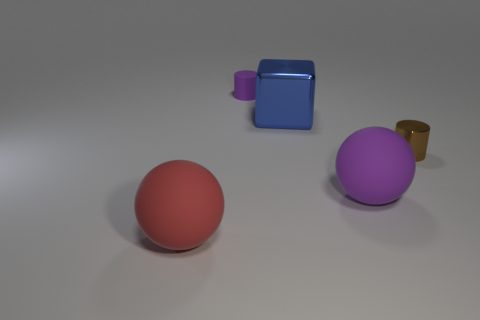Add 2 small purple cylinders. How many objects exist? 7 Subtract 1 cylinders. How many cylinders are left? 1 Add 4 tiny brown cylinders. How many tiny brown cylinders exist? 5 Subtract all purple cylinders. How many cylinders are left? 1 Subtract 0 cyan spheres. How many objects are left? 5 Subtract all cylinders. How many objects are left? 3 Subtract all brown cubes. Subtract all gray cylinders. How many cubes are left? 1 Subtract all blue blocks. How many green cylinders are left? 0 Subtract all big metal cylinders. Subtract all tiny metallic cylinders. How many objects are left? 4 Add 4 brown cylinders. How many brown cylinders are left? 5 